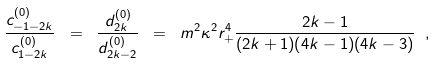<formula> <loc_0><loc_0><loc_500><loc_500>\frac { c _ { - 1 - 2 k } ^ { ( 0 ) } } { c _ { 1 - 2 k } ^ { ( 0 ) } } \ = \ \frac { d _ { 2 k } ^ { ( 0 ) } } { d _ { 2 k - 2 } ^ { ( 0 ) } } \ = \ m ^ { 2 } \kappa ^ { 2 } r _ { + } ^ { 4 } \frac { 2 k - 1 } { ( 2 k + 1 ) ( 4 k - 1 ) ( 4 k - 3 ) } \ ,</formula> 